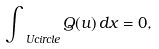<formula> <loc_0><loc_0><loc_500><loc_500>\int _ { \ U c i r c l e } Q ( u ) \, d x = 0 ,</formula> 